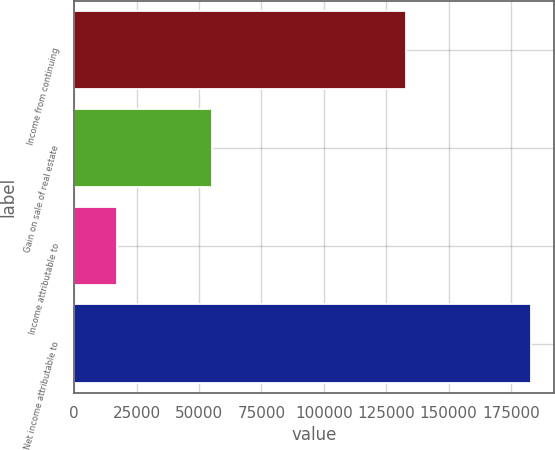<chart> <loc_0><loc_0><loc_500><loc_500><bar_chart><fcel>Income from continuing<fcel>Gain on sale of real estate<fcel>Income attributable to<fcel>Net income attributable to<nl><fcel>132774<fcel>55077<fcel>16951.8<fcel>182961<nl></chart> 